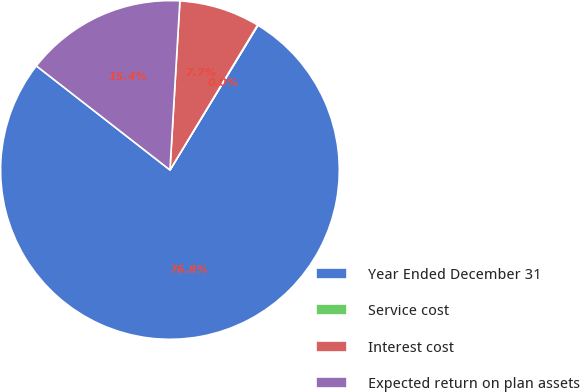<chart> <loc_0><loc_0><loc_500><loc_500><pie_chart><fcel>Year Ended December 31<fcel>Service cost<fcel>Interest cost<fcel>Expected return on plan assets<nl><fcel>76.84%<fcel>0.04%<fcel>7.72%<fcel>15.4%<nl></chart> 